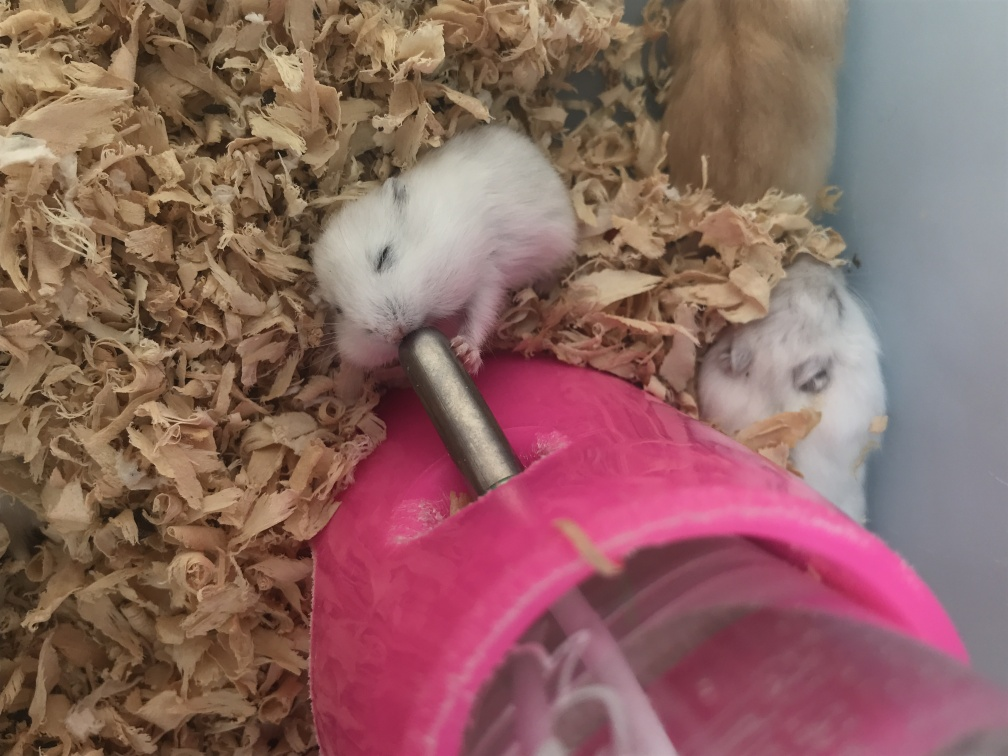What could make this photo more appealing? Improving the focus to bring the subjects into sharp relief would enhance the photo's appeal. Better lighting to illuminate the hamsters evenly and repositioning to capture their faces and expressions would create a more engaging image. Additionally, removing extraneous elements or using a backdrop that doesn't distract from the subjects could also help. 